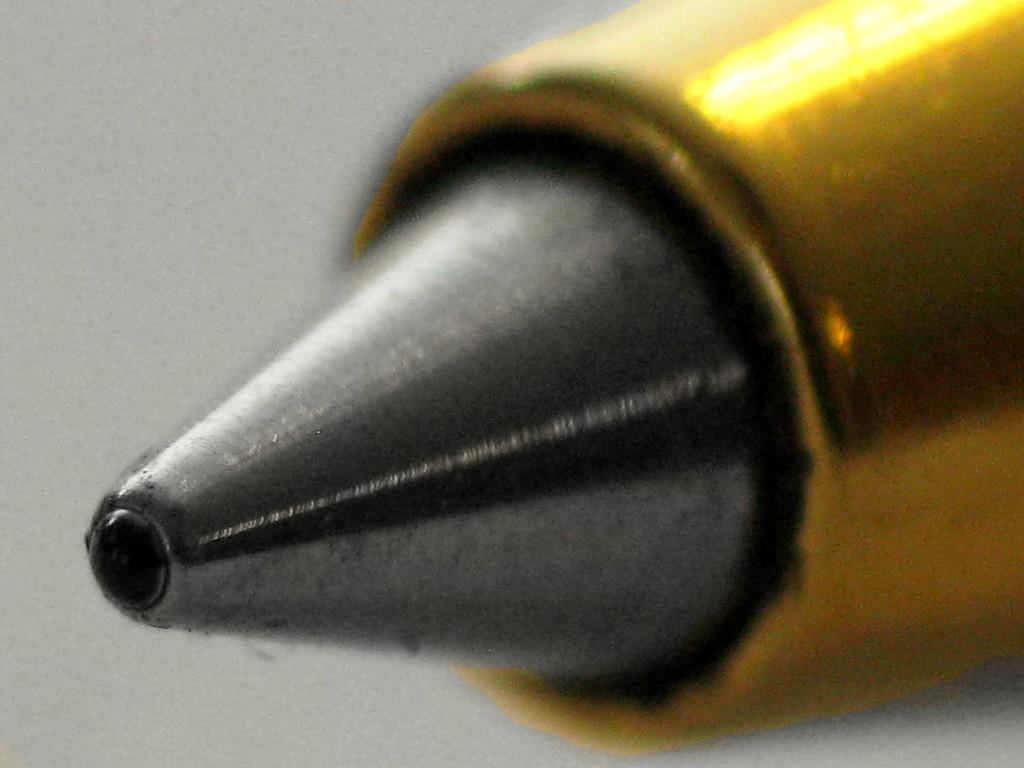What type of object can be seen on the right side of the image? There is a metal object in the image that looks like a bullet on the right side. What is the color of the background in the image? The background of the image is white in color. What type of dress is the zephyr wearing in the image? There is no zephyr or dress present in the image. 